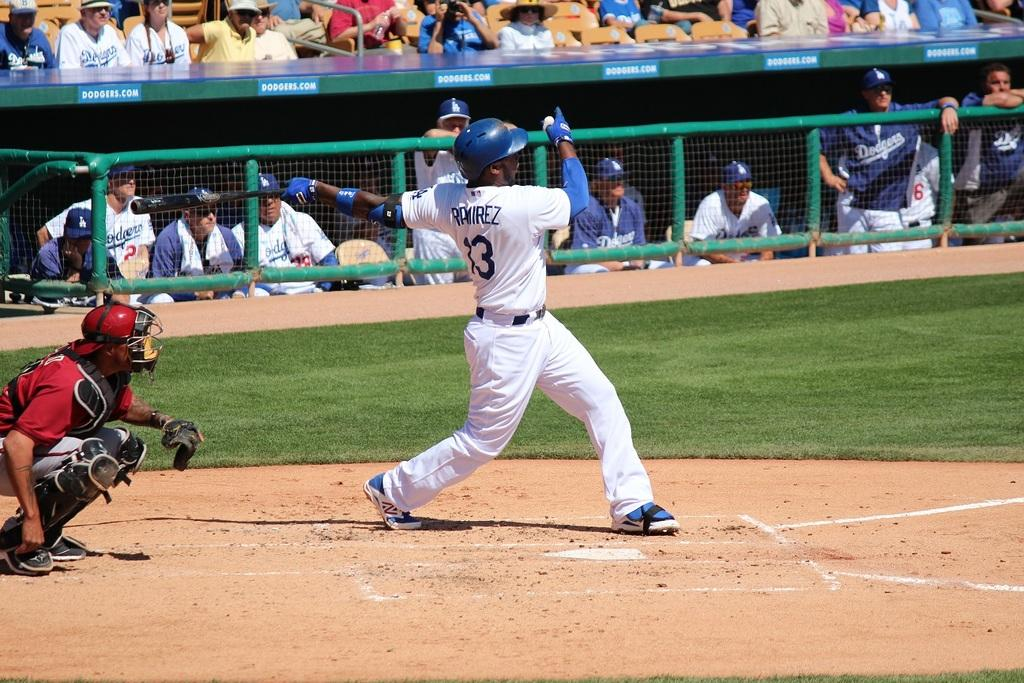<image>
Share a concise interpretation of the image provided. The stadium the players are in is advertised at dodgers.com. 